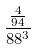<formula> <loc_0><loc_0><loc_500><loc_500>\frac { \frac { 4 } { 9 4 } } { 8 8 ^ { 3 } }</formula> 